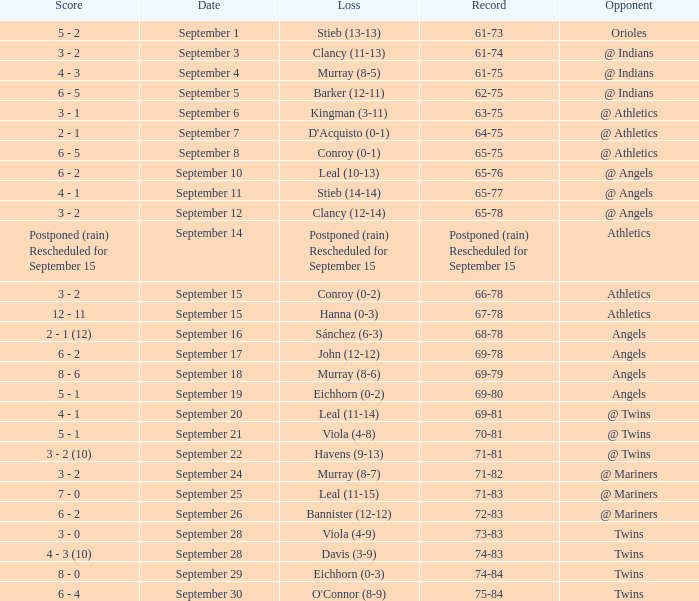Name the date for record of 74-84 September 29. 